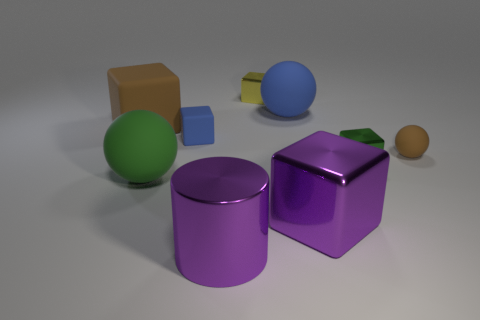Subtract all purple blocks. How many blocks are left? 4 Subtract all small rubber cubes. How many cubes are left? 4 Subtract 2 blocks. How many blocks are left? 3 Subtract all gray cubes. Subtract all cyan spheres. How many cubes are left? 5 Add 1 large purple cubes. How many objects exist? 10 Subtract all blocks. How many objects are left? 4 Subtract 0 gray blocks. How many objects are left? 9 Subtract all metallic cubes. Subtract all brown matte spheres. How many objects are left? 5 Add 1 green metal cubes. How many green metal cubes are left? 2 Add 7 tiny blue rubber objects. How many tiny blue rubber objects exist? 8 